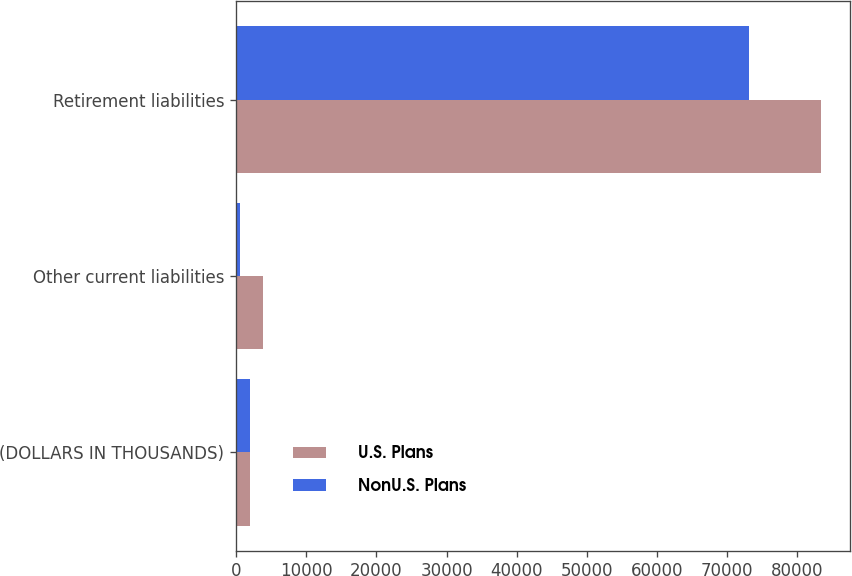<chart> <loc_0><loc_0><loc_500><loc_500><stacked_bar_chart><ecel><fcel>(DOLLARS IN THOUSANDS)<fcel>Other current liabilities<fcel>Retirement liabilities<nl><fcel>U.S. Plans<fcel>2015<fcel>3866<fcel>83334<nl><fcel>NonU.S. Plans<fcel>2015<fcel>613<fcel>73109<nl></chart> 